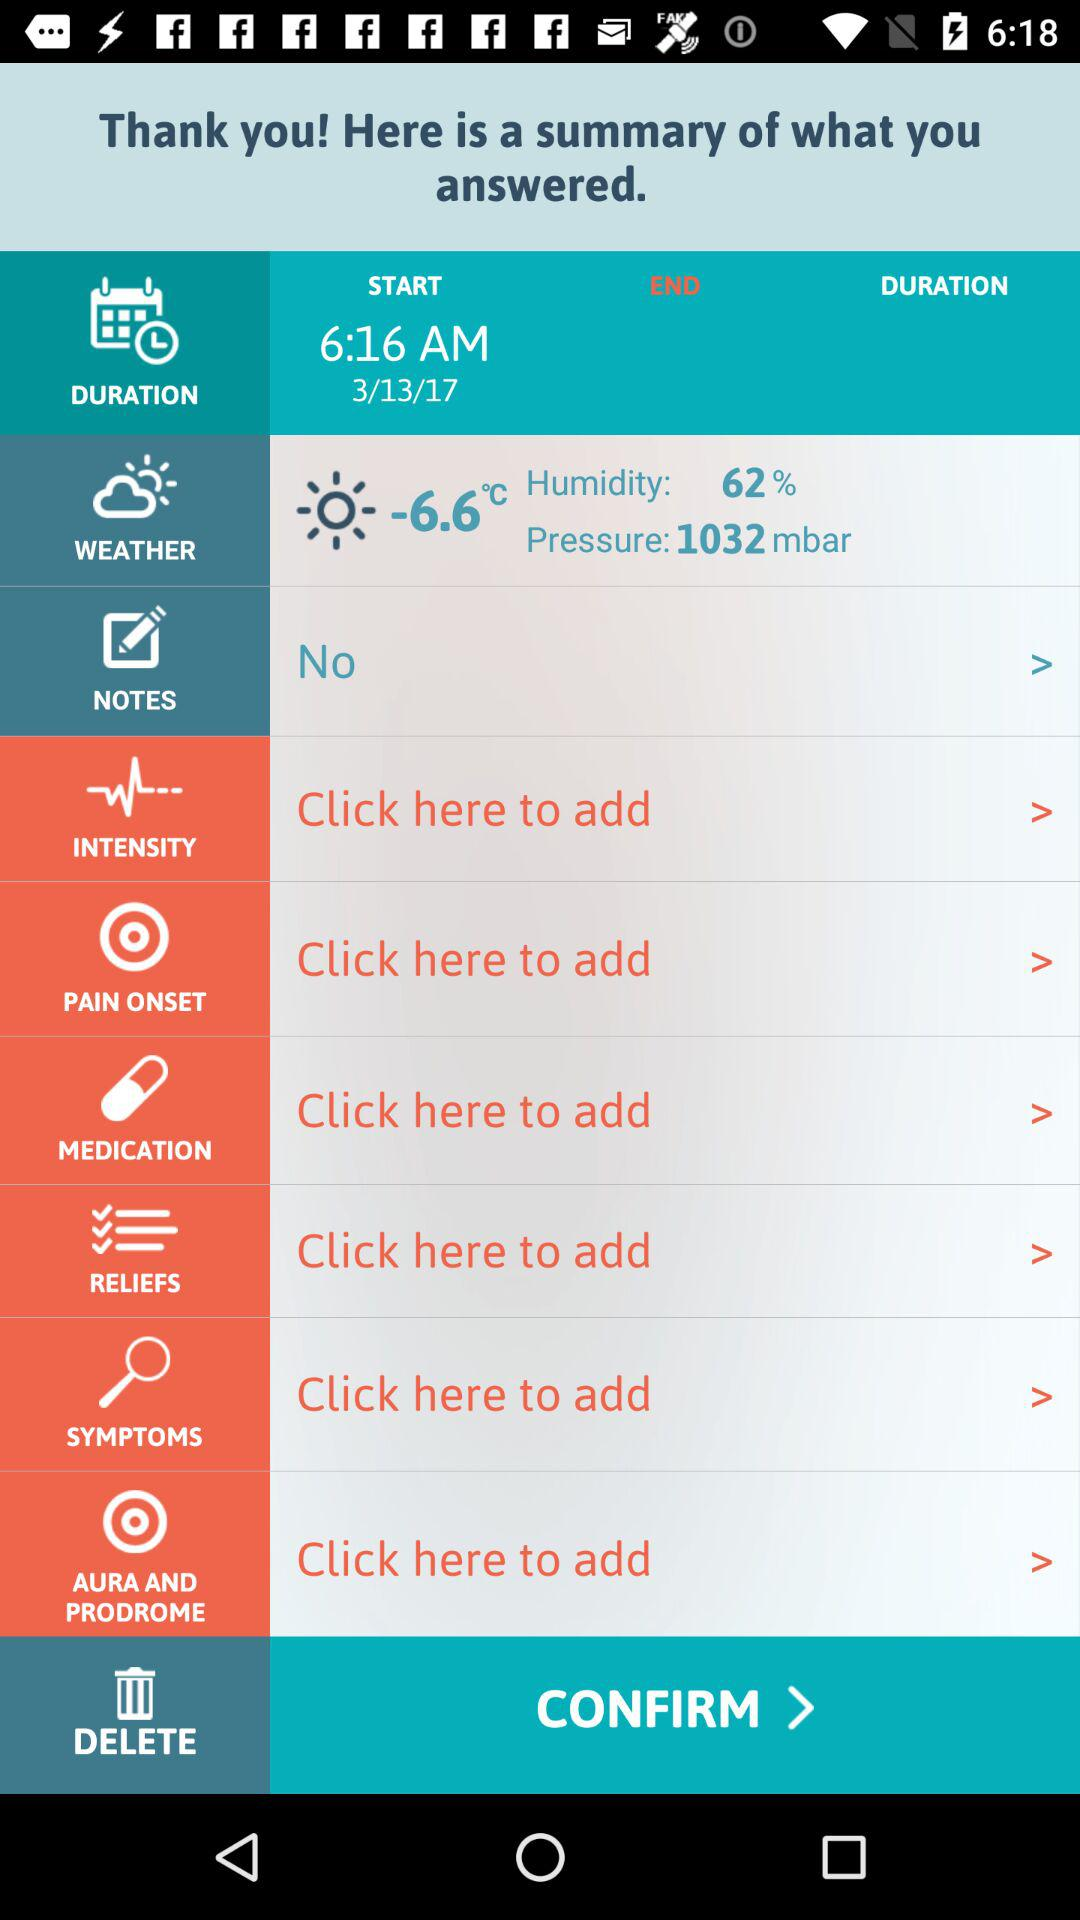What is the temperature? The temperature is -6.6° Celsius. 